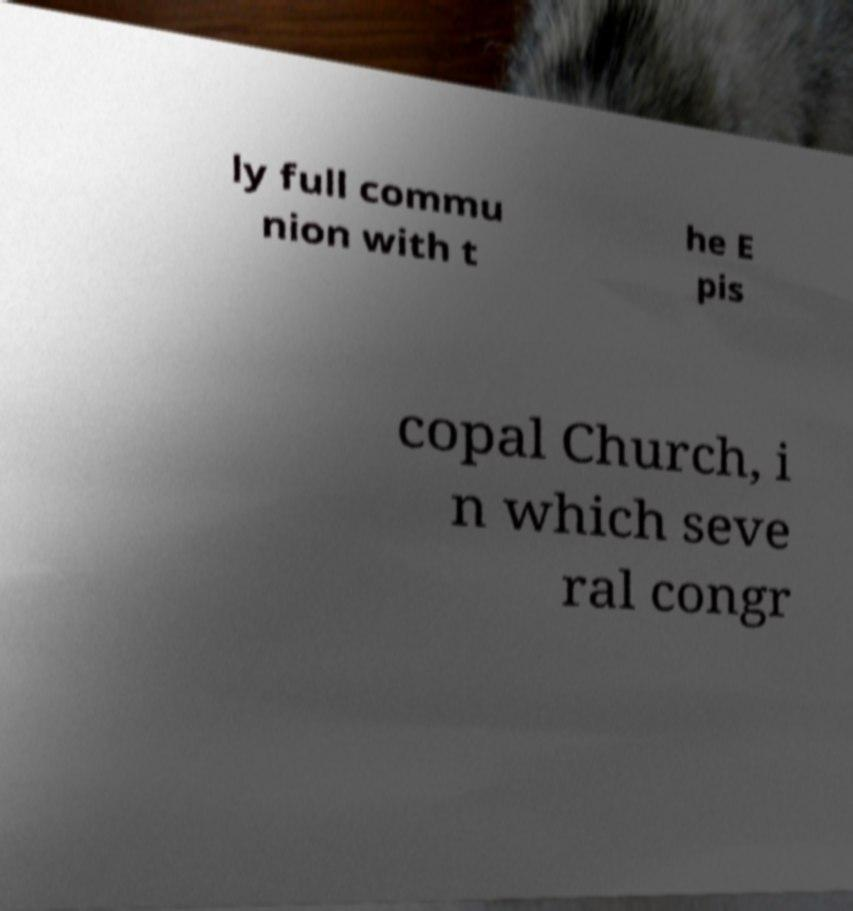I need the written content from this picture converted into text. Can you do that? ly full commu nion with t he E pis copal Church, i n which seve ral congr 